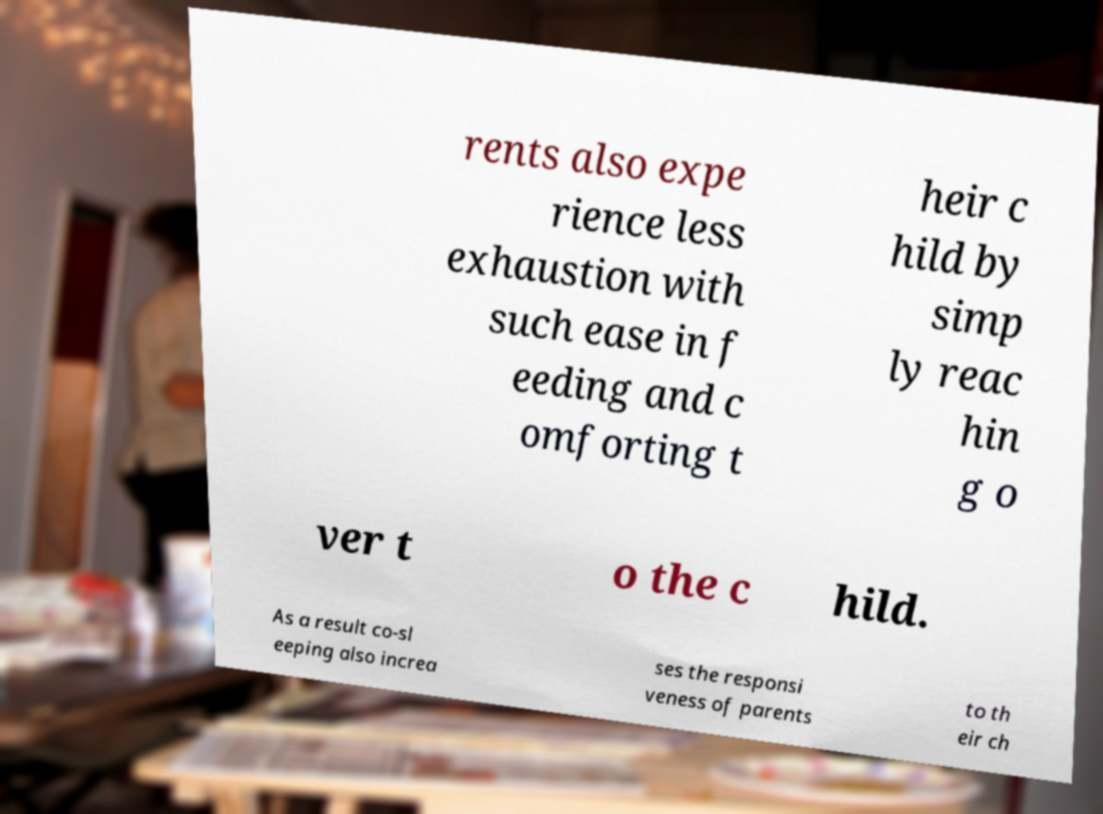Please read and relay the text visible in this image. What does it say? rents also expe rience less exhaustion with such ease in f eeding and c omforting t heir c hild by simp ly reac hin g o ver t o the c hild. As a result co-sl eeping also increa ses the responsi veness of parents to th eir ch 